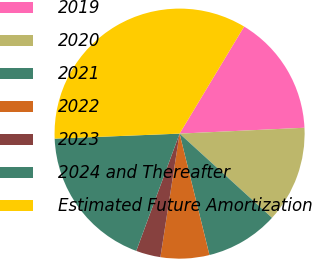Convert chart to OTSL. <chart><loc_0><loc_0><loc_500><loc_500><pie_chart><fcel>2019<fcel>2020<fcel>2021<fcel>2022<fcel>2023<fcel>2024 and Thereafter<fcel>Estimated Future Amortization<nl><fcel>15.62%<fcel>12.51%<fcel>9.4%<fcel>6.29%<fcel>3.18%<fcel>18.73%<fcel>34.27%<nl></chart> 